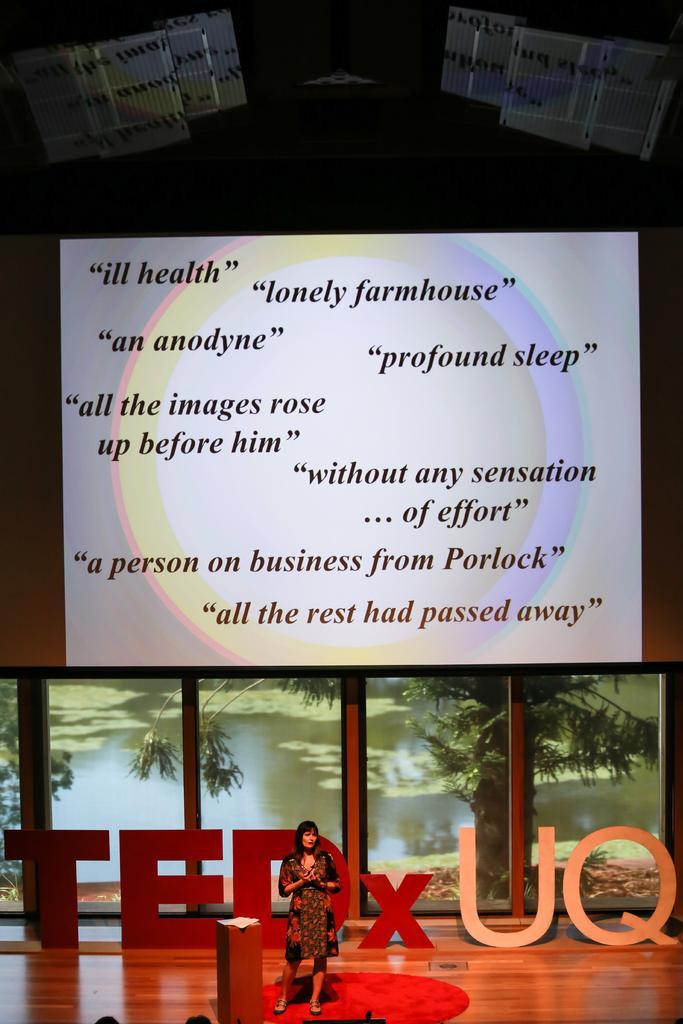Could you give a brief overview of what you see in this image? In the picture I can see a woman is standing on the stage. In the background I can see photos of trees, a board which has something written on it and some other objects on the stage. 